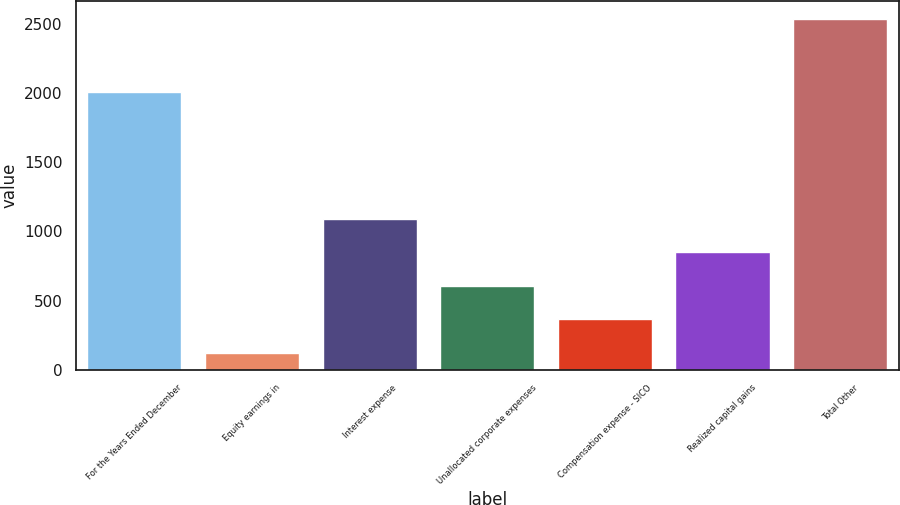Convert chart to OTSL. <chart><loc_0><loc_0><loc_500><loc_500><bar_chart><fcel>For the Years Ended December<fcel>Equity earnings in<fcel>Interest expense<fcel>Unallocated corporate expenses<fcel>Compensation expense - SICO<fcel>Realized capital gains<fcel>Total Other<nl><fcel>2005<fcel>124<fcel>1088.4<fcel>606.2<fcel>365.1<fcel>847.3<fcel>2535<nl></chart> 